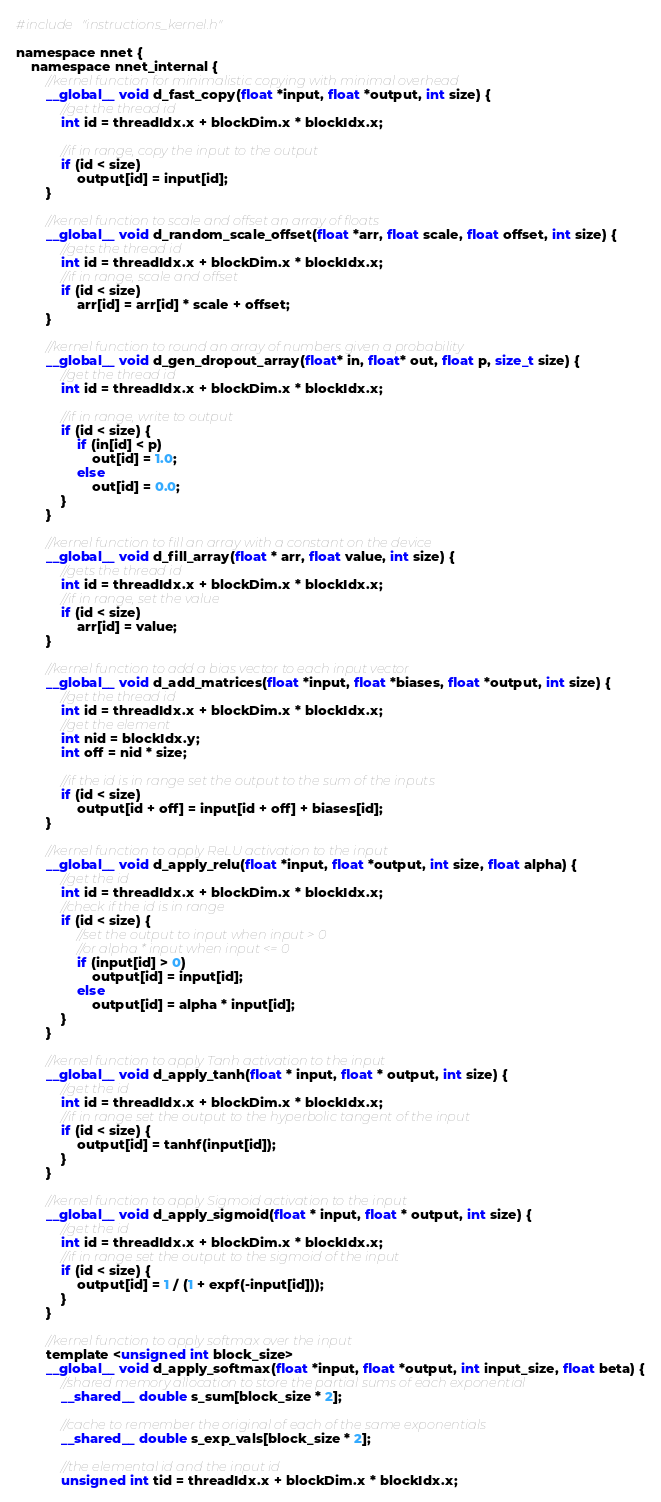Convert code to text. <code><loc_0><loc_0><loc_500><loc_500><_Cuda_>#include "instructions_kernel.h"

namespace nnet {
	namespace nnet_internal {
		//kernel function for minimalistic copying with minimal overhead
		__global__ void d_fast_copy(float *input, float *output, int size) {
			//get the thread id 
			int id = threadIdx.x + blockDim.x * blockIdx.x;

			//if in range, copy the input to the output
			if (id < size)
				output[id] = input[id];
		}

		//kernel function to scale and offset an array of floats
		__global__ void d_random_scale_offset(float *arr, float scale, float offset, int size) {
			//gets the thread id
			int id = threadIdx.x + blockDim.x * blockIdx.x;
			//if in range, scale and offset
			if (id < size)
				arr[id] = arr[id] * scale + offset;
		}

		//kernel function to round an array of numbers given a probability
		__global__ void d_gen_dropout_array(float* in, float* out, float p, size_t size) {
			//get the thread id
			int id = threadIdx.x + blockDim.x * blockIdx.x;

			//if in range, write to output
			if (id < size) {
				if (in[id] < p)
					out[id] = 1.0;
				else
					out[id] = 0.0;
			}
		}

		//kernel function to fill an array with a constant on the device
		__global__ void d_fill_array(float * arr, float value, int size) {
			//gets the thread id
			int id = threadIdx.x + blockDim.x * blockIdx.x;
			//if in range, set the value
			if (id < size)
				arr[id] = value;
		}

		//kernel function to add a bias vector to each input vector
		__global__ void d_add_matrices(float *input, float *biases, float *output, int size) {
			//get the thread id
			int id = threadIdx.x + blockDim.x * blockIdx.x;
			//get the element
			int nid = blockIdx.y;
			int off = nid * size;

			//if the id is in range set the output to the sum of the inputs
			if (id < size)
				output[id + off] = input[id + off] + biases[id];
		}

		//kernel function to apply ReLU activation to the input
		__global__ void d_apply_relu(float *input, float *output, int size, float alpha) {
			//get the id
			int id = threadIdx.x + blockDim.x * blockIdx.x;
			//check if the id is in range
			if (id < size) {
				//set the output to input when input > 0
				//or alpha * input when input <= 0
				if (input[id] > 0)
					output[id] = input[id];
				else
					output[id] = alpha * input[id];
			}
		}

		//kernel function to apply Tanh activation to the input
		__global__ void d_apply_tanh(float * input, float * output, int size) {
			//get the id
			int id = threadIdx.x + blockDim.x * blockIdx.x;
			//if in range set the output to the hyperbolic tangent of the input
			if (id < size) {
				output[id] = tanhf(input[id]);
			}
		}

		//kernel function to apply Sigmoid activation to the input
		__global__ void d_apply_sigmoid(float * input, float * output, int size) {
			//get the id
			int id = threadIdx.x + blockDim.x * blockIdx.x;
			//if in range set the output to the sigmoid of the input
			if (id < size) {
				output[id] = 1 / (1 + expf(-input[id]));
			}
		}

		//kernel function to apply softmax over the input
		template <unsigned int block_size>
		__global__ void d_apply_softmax(float *input, float *output, int input_size, float beta) {
			//shared memory allocation to store the partial sums of each exponential
			__shared__ double s_sum[block_size * 2];

			//cache to remember the original of each of the same exponentials
			__shared__ double s_exp_vals[block_size * 2];

			//the elemental id and the input id
			unsigned int tid = threadIdx.x + blockDim.x * blockIdx.x;</code> 